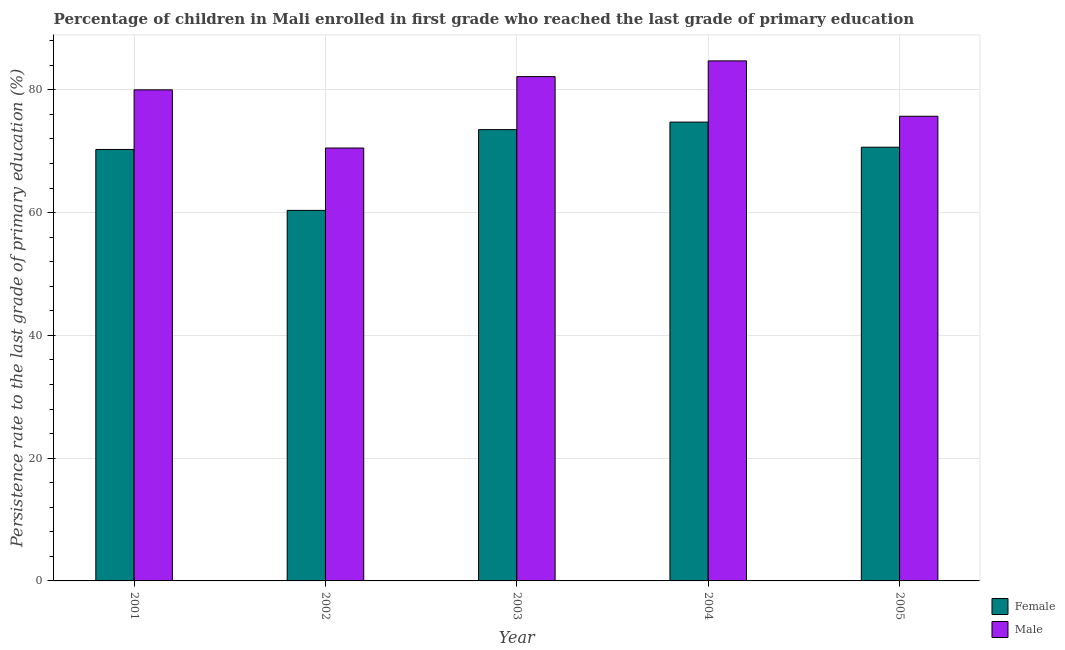How many different coloured bars are there?
Offer a very short reply. 2. How many groups of bars are there?
Offer a very short reply. 5. Are the number of bars per tick equal to the number of legend labels?
Your answer should be very brief. Yes. Are the number of bars on each tick of the X-axis equal?
Make the answer very short. Yes. How many bars are there on the 1st tick from the left?
Give a very brief answer. 2. What is the persistence rate of female students in 2005?
Offer a very short reply. 70.65. Across all years, what is the maximum persistence rate of male students?
Your answer should be compact. 84.71. Across all years, what is the minimum persistence rate of male students?
Your answer should be compact. 70.52. In which year was the persistence rate of female students maximum?
Ensure brevity in your answer.  2004. What is the total persistence rate of male students in the graph?
Make the answer very short. 393.07. What is the difference between the persistence rate of male students in 2002 and that in 2005?
Offer a very short reply. -5.17. What is the difference between the persistence rate of female students in 2005 and the persistence rate of male students in 2001?
Your answer should be compact. 0.37. What is the average persistence rate of male students per year?
Offer a very short reply. 78.61. In the year 2003, what is the difference between the persistence rate of female students and persistence rate of male students?
Your answer should be very brief. 0. In how many years, is the persistence rate of female students greater than 48 %?
Give a very brief answer. 5. What is the ratio of the persistence rate of male students in 2001 to that in 2005?
Offer a very short reply. 1.06. Is the persistence rate of female students in 2002 less than that in 2005?
Offer a terse response. Yes. Is the difference between the persistence rate of female students in 2002 and 2003 greater than the difference between the persistence rate of male students in 2002 and 2003?
Provide a short and direct response. No. What is the difference between the highest and the second highest persistence rate of male students?
Your answer should be compact. 2.56. What is the difference between the highest and the lowest persistence rate of female students?
Your answer should be very brief. 14.38. In how many years, is the persistence rate of male students greater than the average persistence rate of male students taken over all years?
Your answer should be compact. 3. What does the 2nd bar from the right in 2001 represents?
Provide a succinct answer. Female. How many years are there in the graph?
Offer a terse response. 5. What is the difference between two consecutive major ticks on the Y-axis?
Offer a very short reply. 20. Does the graph contain any zero values?
Give a very brief answer. No. Where does the legend appear in the graph?
Provide a short and direct response. Bottom right. How are the legend labels stacked?
Your answer should be compact. Vertical. What is the title of the graph?
Offer a terse response. Percentage of children in Mali enrolled in first grade who reached the last grade of primary education. Does "Electricity" appear as one of the legend labels in the graph?
Make the answer very short. No. What is the label or title of the Y-axis?
Your response must be concise. Persistence rate to the last grade of primary education (%). What is the Persistence rate to the last grade of primary education (%) of Female in 2001?
Offer a terse response. 70.28. What is the Persistence rate to the last grade of primary education (%) of Male in 2001?
Provide a succinct answer. 79.99. What is the Persistence rate to the last grade of primary education (%) of Female in 2002?
Your answer should be very brief. 60.36. What is the Persistence rate to the last grade of primary education (%) of Male in 2002?
Offer a very short reply. 70.52. What is the Persistence rate to the last grade of primary education (%) in Female in 2003?
Ensure brevity in your answer.  73.51. What is the Persistence rate to the last grade of primary education (%) of Male in 2003?
Offer a very short reply. 82.15. What is the Persistence rate to the last grade of primary education (%) in Female in 2004?
Your answer should be very brief. 74.74. What is the Persistence rate to the last grade of primary education (%) in Male in 2004?
Offer a very short reply. 84.71. What is the Persistence rate to the last grade of primary education (%) of Female in 2005?
Your response must be concise. 70.65. What is the Persistence rate to the last grade of primary education (%) of Male in 2005?
Ensure brevity in your answer.  75.69. Across all years, what is the maximum Persistence rate to the last grade of primary education (%) of Female?
Keep it short and to the point. 74.74. Across all years, what is the maximum Persistence rate to the last grade of primary education (%) of Male?
Ensure brevity in your answer.  84.71. Across all years, what is the minimum Persistence rate to the last grade of primary education (%) of Female?
Offer a very short reply. 60.36. Across all years, what is the minimum Persistence rate to the last grade of primary education (%) of Male?
Give a very brief answer. 70.52. What is the total Persistence rate to the last grade of primary education (%) in Female in the graph?
Your answer should be compact. 349.55. What is the total Persistence rate to the last grade of primary education (%) in Male in the graph?
Provide a succinct answer. 393.07. What is the difference between the Persistence rate to the last grade of primary education (%) of Female in 2001 and that in 2002?
Keep it short and to the point. 9.92. What is the difference between the Persistence rate to the last grade of primary education (%) in Male in 2001 and that in 2002?
Your response must be concise. 9.48. What is the difference between the Persistence rate to the last grade of primary education (%) in Female in 2001 and that in 2003?
Provide a succinct answer. -3.23. What is the difference between the Persistence rate to the last grade of primary education (%) in Male in 2001 and that in 2003?
Make the answer very short. -2.16. What is the difference between the Persistence rate to the last grade of primary education (%) of Female in 2001 and that in 2004?
Your answer should be compact. -4.46. What is the difference between the Persistence rate to the last grade of primary education (%) of Male in 2001 and that in 2004?
Your answer should be very brief. -4.72. What is the difference between the Persistence rate to the last grade of primary education (%) of Female in 2001 and that in 2005?
Offer a very short reply. -0.37. What is the difference between the Persistence rate to the last grade of primary education (%) of Male in 2001 and that in 2005?
Offer a terse response. 4.3. What is the difference between the Persistence rate to the last grade of primary education (%) in Female in 2002 and that in 2003?
Your response must be concise. -13.16. What is the difference between the Persistence rate to the last grade of primary education (%) of Male in 2002 and that in 2003?
Your answer should be compact. -11.63. What is the difference between the Persistence rate to the last grade of primary education (%) of Female in 2002 and that in 2004?
Offer a terse response. -14.38. What is the difference between the Persistence rate to the last grade of primary education (%) in Male in 2002 and that in 2004?
Give a very brief answer. -14.2. What is the difference between the Persistence rate to the last grade of primary education (%) of Female in 2002 and that in 2005?
Your answer should be compact. -10.29. What is the difference between the Persistence rate to the last grade of primary education (%) in Male in 2002 and that in 2005?
Your answer should be compact. -5.17. What is the difference between the Persistence rate to the last grade of primary education (%) of Female in 2003 and that in 2004?
Provide a succinct answer. -1.22. What is the difference between the Persistence rate to the last grade of primary education (%) of Male in 2003 and that in 2004?
Give a very brief answer. -2.56. What is the difference between the Persistence rate to the last grade of primary education (%) in Female in 2003 and that in 2005?
Give a very brief answer. 2.86. What is the difference between the Persistence rate to the last grade of primary education (%) of Male in 2003 and that in 2005?
Ensure brevity in your answer.  6.46. What is the difference between the Persistence rate to the last grade of primary education (%) of Female in 2004 and that in 2005?
Make the answer very short. 4.09. What is the difference between the Persistence rate to the last grade of primary education (%) of Male in 2004 and that in 2005?
Offer a terse response. 9.02. What is the difference between the Persistence rate to the last grade of primary education (%) in Female in 2001 and the Persistence rate to the last grade of primary education (%) in Male in 2002?
Offer a terse response. -0.23. What is the difference between the Persistence rate to the last grade of primary education (%) of Female in 2001 and the Persistence rate to the last grade of primary education (%) of Male in 2003?
Give a very brief answer. -11.87. What is the difference between the Persistence rate to the last grade of primary education (%) in Female in 2001 and the Persistence rate to the last grade of primary education (%) in Male in 2004?
Provide a succinct answer. -14.43. What is the difference between the Persistence rate to the last grade of primary education (%) in Female in 2001 and the Persistence rate to the last grade of primary education (%) in Male in 2005?
Ensure brevity in your answer.  -5.41. What is the difference between the Persistence rate to the last grade of primary education (%) in Female in 2002 and the Persistence rate to the last grade of primary education (%) in Male in 2003?
Provide a short and direct response. -21.79. What is the difference between the Persistence rate to the last grade of primary education (%) of Female in 2002 and the Persistence rate to the last grade of primary education (%) of Male in 2004?
Your response must be concise. -24.35. What is the difference between the Persistence rate to the last grade of primary education (%) of Female in 2002 and the Persistence rate to the last grade of primary education (%) of Male in 2005?
Provide a short and direct response. -15.33. What is the difference between the Persistence rate to the last grade of primary education (%) of Female in 2003 and the Persistence rate to the last grade of primary education (%) of Male in 2004?
Offer a very short reply. -11.2. What is the difference between the Persistence rate to the last grade of primary education (%) of Female in 2003 and the Persistence rate to the last grade of primary education (%) of Male in 2005?
Provide a succinct answer. -2.18. What is the difference between the Persistence rate to the last grade of primary education (%) in Female in 2004 and the Persistence rate to the last grade of primary education (%) in Male in 2005?
Make the answer very short. -0.95. What is the average Persistence rate to the last grade of primary education (%) of Female per year?
Offer a very short reply. 69.91. What is the average Persistence rate to the last grade of primary education (%) of Male per year?
Offer a very short reply. 78.61. In the year 2001, what is the difference between the Persistence rate to the last grade of primary education (%) in Female and Persistence rate to the last grade of primary education (%) in Male?
Ensure brevity in your answer.  -9.71. In the year 2002, what is the difference between the Persistence rate to the last grade of primary education (%) in Female and Persistence rate to the last grade of primary education (%) in Male?
Provide a succinct answer. -10.16. In the year 2003, what is the difference between the Persistence rate to the last grade of primary education (%) in Female and Persistence rate to the last grade of primary education (%) in Male?
Keep it short and to the point. -8.64. In the year 2004, what is the difference between the Persistence rate to the last grade of primary education (%) of Female and Persistence rate to the last grade of primary education (%) of Male?
Ensure brevity in your answer.  -9.97. In the year 2005, what is the difference between the Persistence rate to the last grade of primary education (%) of Female and Persistence rate to the last grade of primary education (%) of Male?
Offer a terse response. -5.04. What is the ratio of the Persistence rate to the last grade of primary education (%) of Female in 2001 to that in 2002?
Keep it short and to the point. 1.16. What is the ratio of the Persistence rate to the last grade of primary education (%) in Male in 2001 to that in 2002?
Provide a short and direct response. 1.13. What is the ratio of the Persistence rate to the last grade of primary education (%) in Female in 2001 to that in 2003?
Your response must be concise. 0.96. What is the ratio of the Persistence rate to the last grade of primary education (%) of Male in 2001 to that in 2003?
Provide a succinct answer. 0.97. What is the ratio of the Persistence rate to the last grade of primary education (%) of Female in 2001 to that in 2004?
Offer a terse response. 0.94. What is the ratio of the Persistence rate to the last grade of primary education (%) in Male in 2001 to that in 2004?
Offer a terse response. 0.94. What is the ratio of the Persistence rate to the last grade of primary education (%) in Female in 2001 to that in 2005?
Your answer should be very brief. 0.99. What is the ratio of the Persistence rate to the last grade of primary education (%) in Male in 2001 to that in 2005?
Ensure brevity in your answer.  1.06. What is the ratio of the Persistence rate to the last grade of primary education (%) in Female in 2002 to that in 2003?
Keep it short and to the point. 0.82. What is the ratio of the Persistence rate to the last grade of primary education (%) of Male in 2002 to that in 2003?
Ensure brevity in your answer.  0.86. What is the ratio of the Persistence rate to the last grade of primary education (%) of Female in 2002 to that in 2004?
Offer a very short reply. 0.81. What is the ratio of the Persistence rate to the last grade of primary education (%) of Male in 2002 to that in 2004?
Offer a terse response. 0.83. What is the ratio of the Persistence rate to the last grade of primary education (%) in Female in 2002 to that in 2005?
Ensure brevity in your answer.  0.85. What is the ratio of the Persistence rate to the last grade of primary education (%) in Male in 2002 to that in 2005?
Provide a short and direct response. 0.93. What is the ratio of the Persistence rate to the last grade of primary education (%) of Female in 2003 to that in 2004?
Give a very brief answer. 0.98. What is the ratio of the Persistence rate to the last grade of primary education (%) in Male in 2003 to that in 2004?
Provide a succinct answer. 0.97. What is the ratio of the Persistence rate to the last grade of primary education (%) in Female in 2003 to that in 2005?
Keep it short and to the point. 1.04. What is the ratio of the Persistence rate to the last grade of primary education (%) of Male in 2003 to that in 2005?
Offer a terse response. 1.09. What is the ratio of the Persistence rate to the last grade of primary education (%) of Female in 2004 to that in 2005?
Make the answer very short. 1.06. What is the ratio of the Persistence rate to the last grade of primary education (%) of Male in 2004 to that in 2005?
Make the answer very short. 1.12. What is the difference between the highest and the second highest Persistence rate to the last grade of primary education (%) of Female?
Ensure brevity in your answer.  1.22. What is the difference between the highest and the second highest Persistence rate to the last grade of primary education (%) in Male?
Make the answer very short. 2.56. What is the difference between the highest and the lowest Persistence rate to the last grade of primary education (%) in Female?
Give a very brief answer. 14.38. What is the difference between the highest and the lowest Persistence rate to the last grade of primary education (%) in Male?
Your answer should be compact. 14.2. 